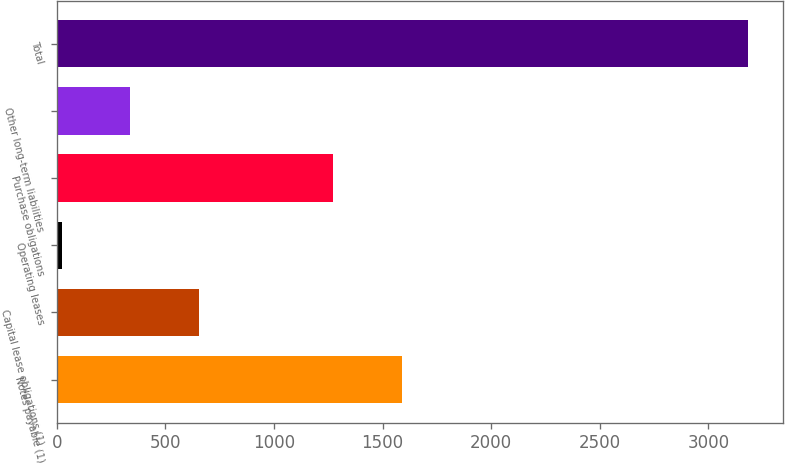Convert chart. <chart><loc_0><loc_0><loc_500><loc_500><bar_chart><fcel>Notes payable (1)<fcel>Capital lease obligations (1)<fcel>Operating leases<fcel>Purchase obligations<fcel>Other long-term liabilities<fcel>Total<nl><fcel>1589.2<fcel>654.4<fcel>22<fcel>1273<fcel>338.2<fcel>3184<nl></chart> 